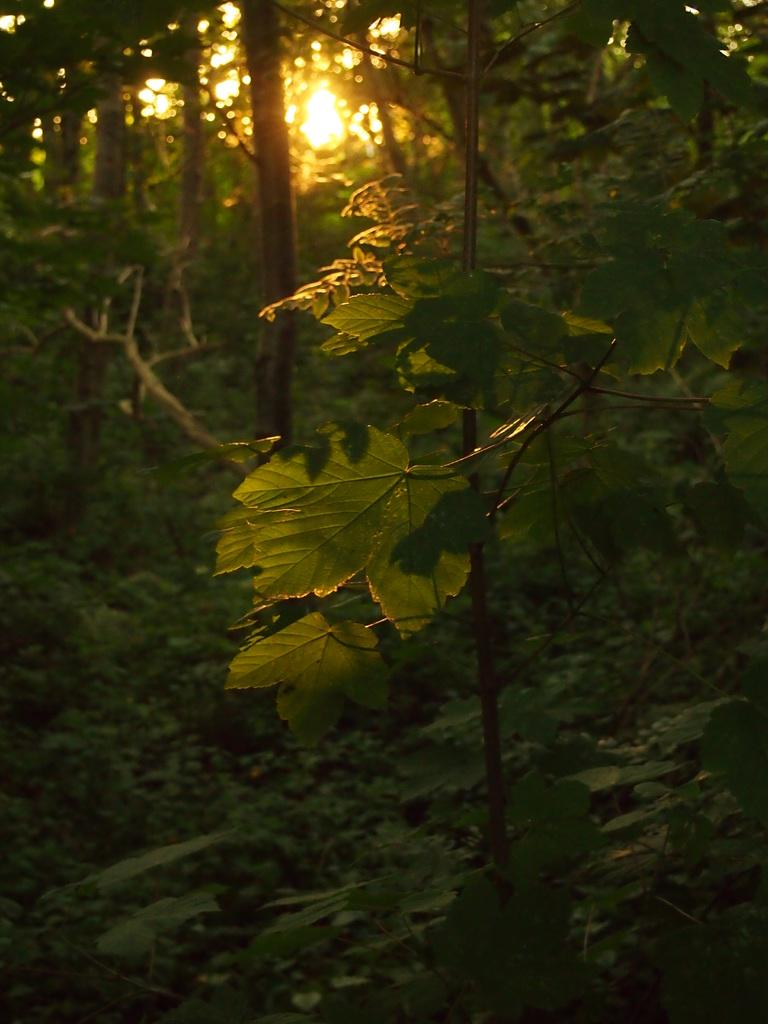What is the main subject of the image? There is a tree in the image. Can you describe the background of the image? There are trees in the background of the image, and the sun is visible. What type of environment might the image depict? The image might have been taken in a forest, given the presence of trees. What type of mint is growing on the tree in the image? There is no mint growing on the tree in the image; it is not mentioned in the provided facts. 